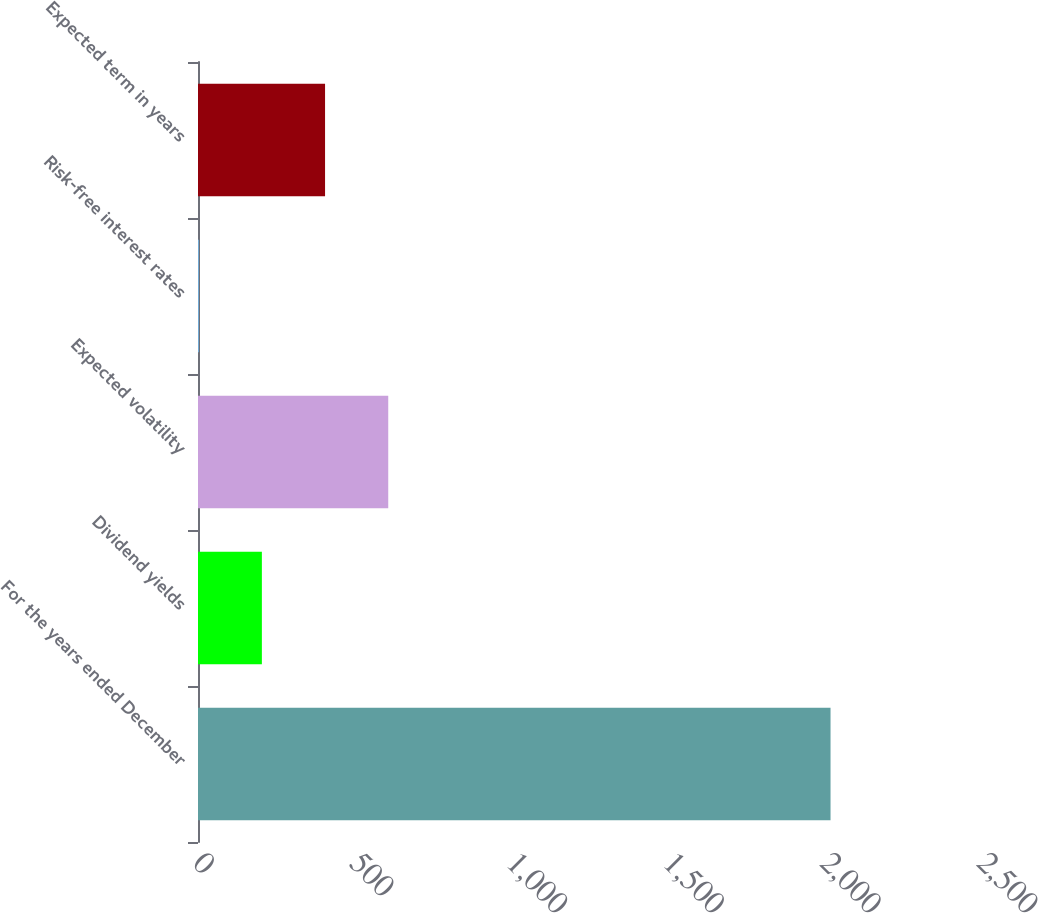Convert chart. <chart><loc_0><loc_0><loc_500><loc_500><bar_chart><fcel>For the years ended December<fcel>Dividend yields<fcel>Expected volatility<fcel>Risk-free interest rates<fcel>Expected term in years<nl><fcel>2017<fcel>203.68<fcel>606.64<fcel>2.2<fcel>405.16<nl></chart> 